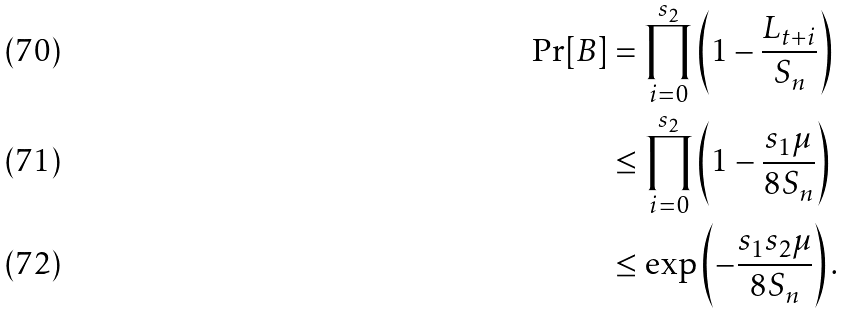Convert formula to latex. <formula><loc_0><loc_0><loc_500><loc_500>\Pr [ B ] & = \prod _ { i = 0 } ^ { s _ { 2 } } \left ( 1 - \frac { L _ { t + i } } { S _ { n } } \right ) \\ & \leq \prod _ { i = 0 } ^ { s _ { 2 } } \left ( 1 - \frac { s _ { 1 } \mu } { 8 S _ { n } } \right ) \\ & \leq \exp \left ( - \frac { s _ { 1 } s _ { 2 } \mu } { 8 S _ { n } } \right ) .</formula> 